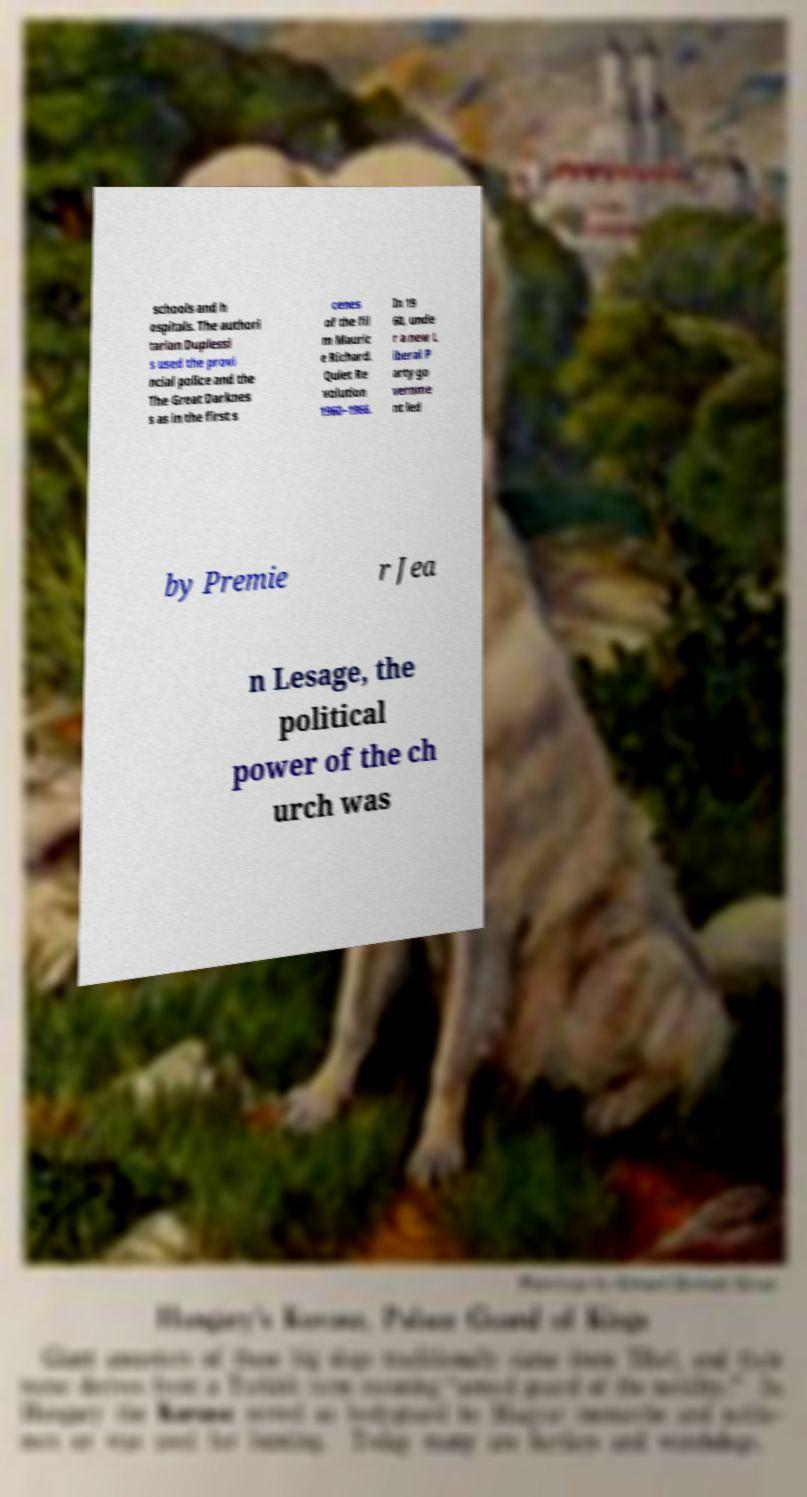Could you extract and type out the text from this image? schools and h ospitals. The authori tarian Duplessi s used the provi ncial police and the The Great Darknes s as in the first s cenes of the fil m Mauric e Richard. Quiet Re volution 1960–1966. In 19 60, unde r a new L iberal P arty go vernme nt led by Premie r Jea n Lesage, the political power of the ch urch was 